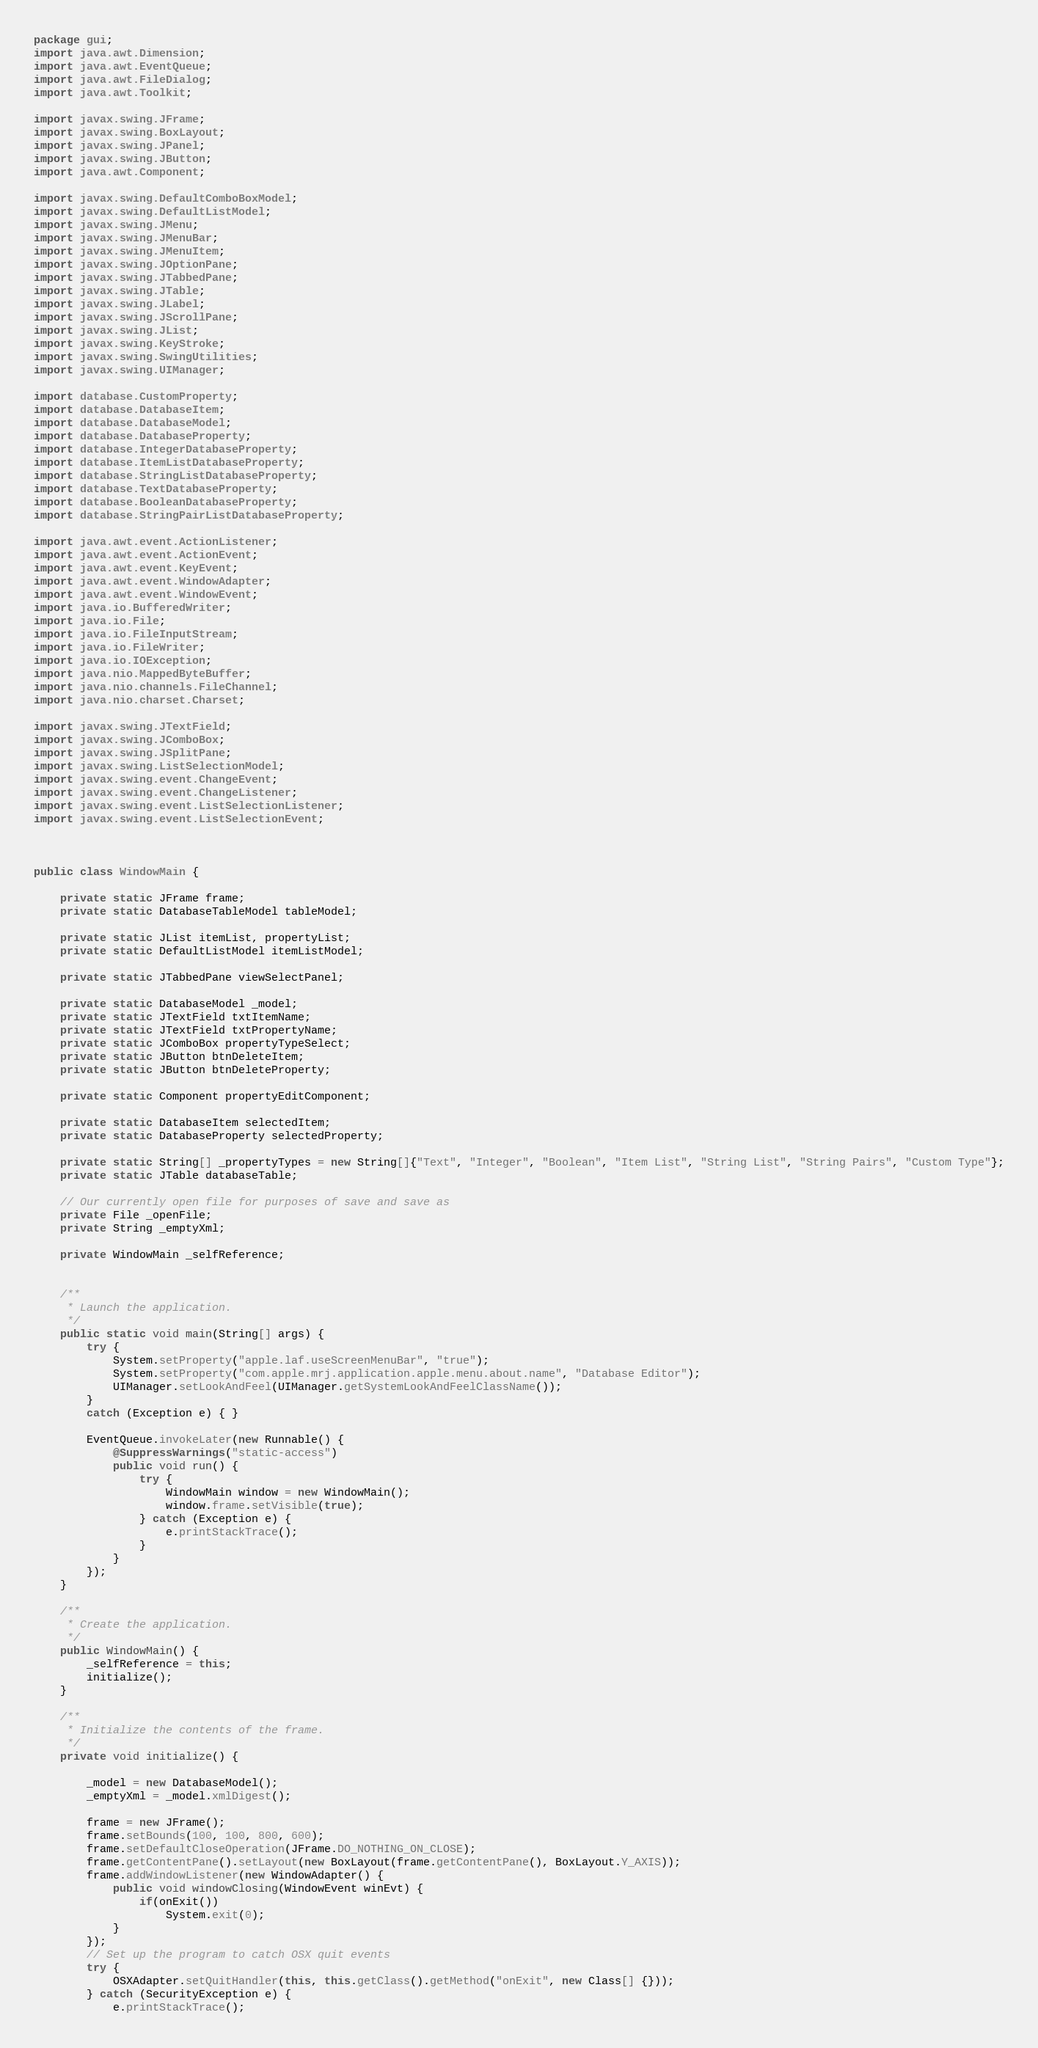Convert code to text. <code><loc_0><loc_0><loc_500><loc_500><_Java_>package gui;
import java.awt.Dimension;
import java.awt.EventQueue;
import java.awt.FileDialog;
import java.awt.Toolkit;

import javax.swing.JFrame;
import javax.swing.BoxLayout;
import javax.swing.JPanel;
import javax.swing.JButton;
import java.awt.Component;

import javax.swing.DefaultComboBoxModel;
import javax.swing.DefaultListModel;
import javax.swing.JMenu;
import javax.swing.JMenuBar;
import javax.swing.JMenuItem;
import javax.swing.JOptionPane;
import javax.swing.JTabbedPane;
import javax.swing.JTable;
import javax.swing.JLabel;
import javax.swing.JScrollPane;
import javax.swing.JList;
import javax.swing.KeyStroke;
import javax.swing.SwingUtilities;
import javax.swing.UIManager;

import database.CustomProperty;
import database.DatabaseItem;
import database.DatabaseModel;
import database.DatabaseProperty;
import database.IntegerDatabaseProperty;
import database.ItemListDatabaseProperty;
import database.StringListDatabaseProperty;
import database.TextDatabaseProperty;
import database.BooleanDatabaseProperty;
import database.StringPairListDatabaseProperty;

import java.awt.event.ActionListener;
import java.awt.event.ActionEvent;
import java.awt.event.KeyEvent;
import java.awt.event.WindowAdapter;
import java.awt.event.WindowEvent;
import java.io.BufferedWriter;
import java.io.File;
import java.io.FileInputStream;
import java.io.FileWriter;
import java.io.IOException;
import java.nio.MappedByteBuffer;
import java.nio.channels.FileChannel;
import java.nio.charset.Charset;

import javax.swing.JTextField;
import javax.swing.JComboBox;
import javax.swing.JSplitPane;
import javax.swing.ListSelectionModel;
import javax.swing.event.ChangeEvent;
import javax.swing.event.ChangeListener;
import javax.swing.event.ListSelectionListener;
import javax.swing.event.ListSelectionEvent;



public class WindowMain {

	private static JFrame frame;
	private static DatabaseTableModel tableModel;

	private static JList itemList, propertyList;
	private static DefaultListModel itemListModel;
	
	private static JTabbedPane viewSelectPanel;
	
	private static DatabaseModel _model;
	private static JTextField txtItemName;
	private static JTextField txtPropertyName;
	private static JComboBox propertyTypeSelect;
	private static JButton btnDeleteItem; 
	private static JButton btnDeleteProperty; 
	
	private static Component propertyEditComponent;
	
	private static DatabaseItem selectedItem; 
	private static DatabaseProperty selectedProperty; 
	
	private static String[] _propertyTypes = new String[]{"Text", "Integer", "Boolean", "Item List", "String List", "String Pairs", "Custom Type"};
	private static JTable databaseTable;
	
	// Our currently open file for purposes of save and save as
	private File _openFile;
	private String _emptyXml;
	
	private WindowMain _selfReference;
	
	
	/**
	 * Launch the application.
	 */
	public static void main(String[] args) {
		try {
			System.setProperty("apple.laf.useScreenMenuBar", "true");
			System.setProperty("com.apple.mrj.application.apple.menu.about.name", "Database Editor");
			UIManager.setLookAndFeel(UIManager.getSystemLookAndFeelClassName());
		}
		catch (Exception e) { }
		
		EventQueue.invokeLater(new Runnable() {
			@SuppressWarnings("static-access")
			public void run() {
				try {
					WindowMain window = new WindowMain();
					window.frame.setVisible(true);
				} catch (Exception e) {
					e.printStackTrace();
				}
			}
		});
	}

	/**
	 * Create the application.
	 */
	public WindowMain() {
		_selfReference = this;
		initialize();
	}

	/**
	 * Initialize the contents of the frame.
	 */
	private void initialize() {
		
		_model = new DatabaseModel();
		_emptyXml = _model.xmlDigest();
		
		frame = new JFrame();
		frame.setBounds(100, 100, 800, 600);
		frame.setDefaultCloseOperation(JFrame.DO_NOTHING_ON_CLOSE);
		frame.getContentPane().setLayout(new BoxLayout(frame.getContentPane(), BoxLayout.Y_AXIS));
		frame.addWindowListener(new WindowAdapter() {
			public void windowClosing(WindowEvent winEvt) {
				if(onExit())
					System.exit(0);
			}
		});
		// Set up the program to catch OSX quit events 
		try {
			OSXAdapter.setQuitHandler(this, this.getClass().getMethod("onExit", new Class[] {}));
		} catch (SecurityException e) {
			e.printStackTrace();</code> 